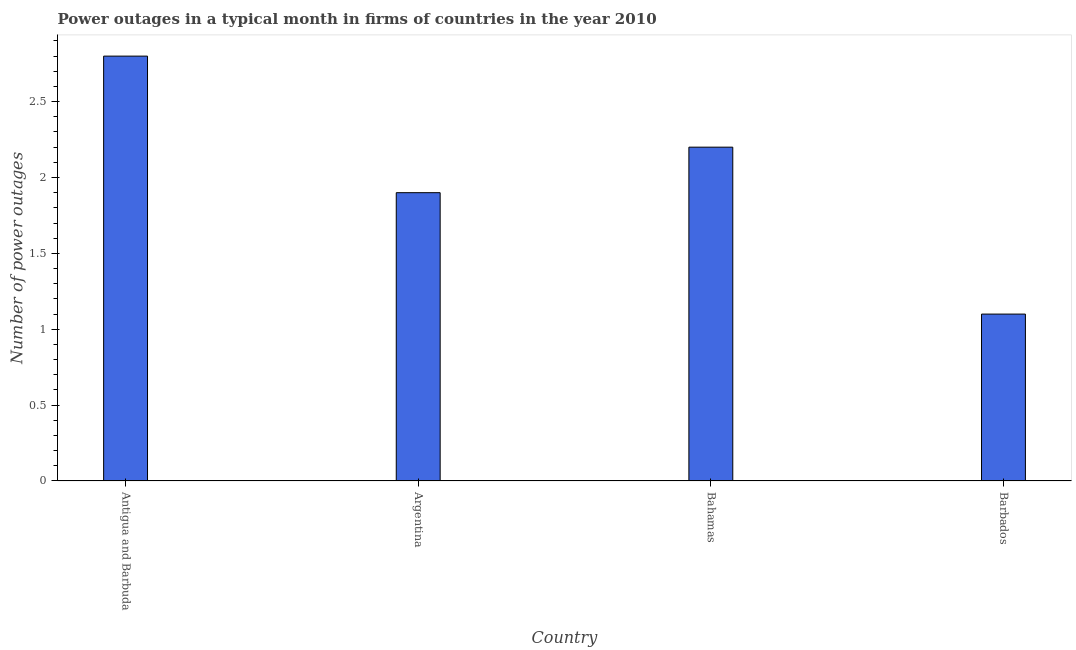Does the graph contain any zero values?
Your answer should be very brief. No. Does the graph contain grids?
Offer a terse response. No. What is the title of the graph?
Provide a short and direct response. Power outages in a typical month in firms of countries in the year 2010. What is the label or title of the Y-axis?
Your answer should be compact. Number of power outages. Across all countries, what is the minimum number of power outages?
Give a very brief answer. 1.1. In which country was the number of power outages maximum?
Keep it short and to the point. Antigua and Barbuda. In which country was the number of power outages minimum?
Keep it short and to the point. Barbados. What is the median number of power outages?
Give a very brief answer. 2.05. In how many countries, is the number of power outages greater than 2.5 ?
Ensure brevity in your answer.  1. What is the ratio of the number of power outages in Antigua and Barbuda to that in Argentina?
Offer a terse response. 1.47. Is the number of power outages in Bahamas less than that in Barbados?
Provide a short and direct response. No. Is the difference between the number of power outages in Argentina and Bahamas greater than the difference between any two countries?
Provide a short and direct response. No. What is the difference between the highest and the lowest number of power outages?
Keep it short and to the point. 1.7. How many bars are there?
Make the answer very short. 4. Are the values on the major ticks of Y-axis written in scientific E-notation?
Make the answer very short. No. What is the Number of power outages in Argentina?
Keep it short and to the point. 1.9. What is the Number of power outages in Bahamas?
Your answer should be compact. 2.2. What is the Number of power outages in Barbados?
Keep it short and to the point. 1.1. What is the difference between the Number of power outages in Argentina and Bahamas?
Give a very brief answer. -0.3. What is the difference between the Number of power outages in Bahamas and Barbados?
Keep it short and to the point. 1.1. What is the ratio of the Number of power outages in Antigua and Barbuda to that in Argentina?
Your answer should be compact. 1.47. What is the ratio of the Number of power outages in Antigua and Barbuda to that in Bahamas?
Your response must be concise. 1.27. What is the ratio of the Number of power outages in Antigua and Barbuda to that in Barbados?
Offer a terse response. 2.54. What is the ratio of the Number of power outages in Argentina to that in Bahamas?
Provide a short and direct response. 0.86. What is the ratio of the Number of power outages in Argentina to that in Barbados?
Your answer should be compact. 1.73. 